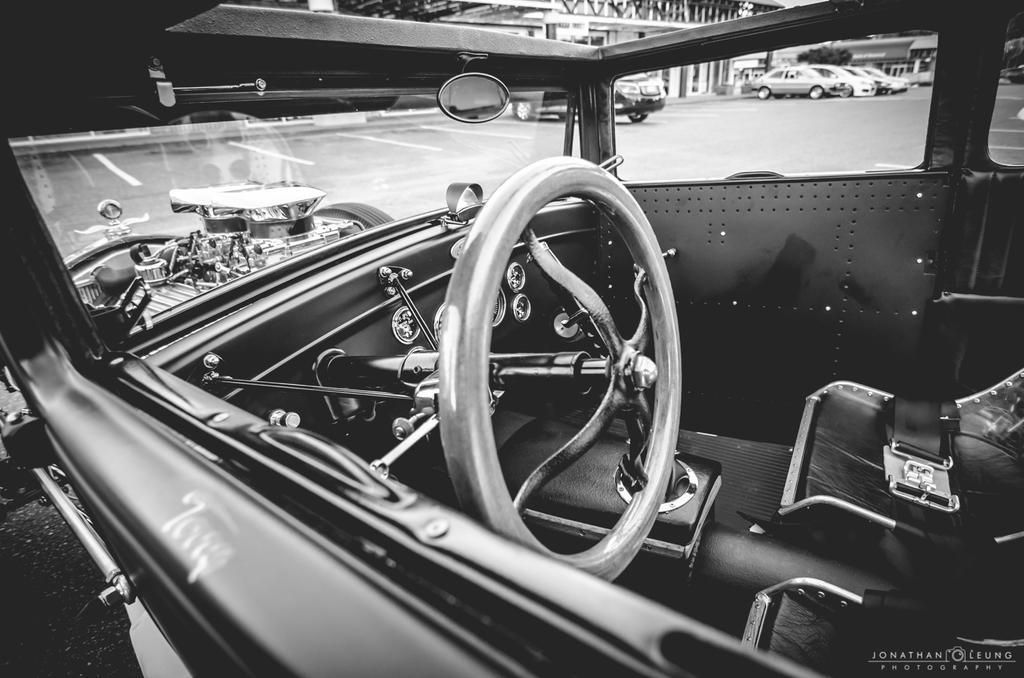Could you give a brief overview of what you see in this image? This image consists of a vintage car. We can see the interior of the car. In the background, there is a road. On which there are many cars parked. On the left, there is a building. 